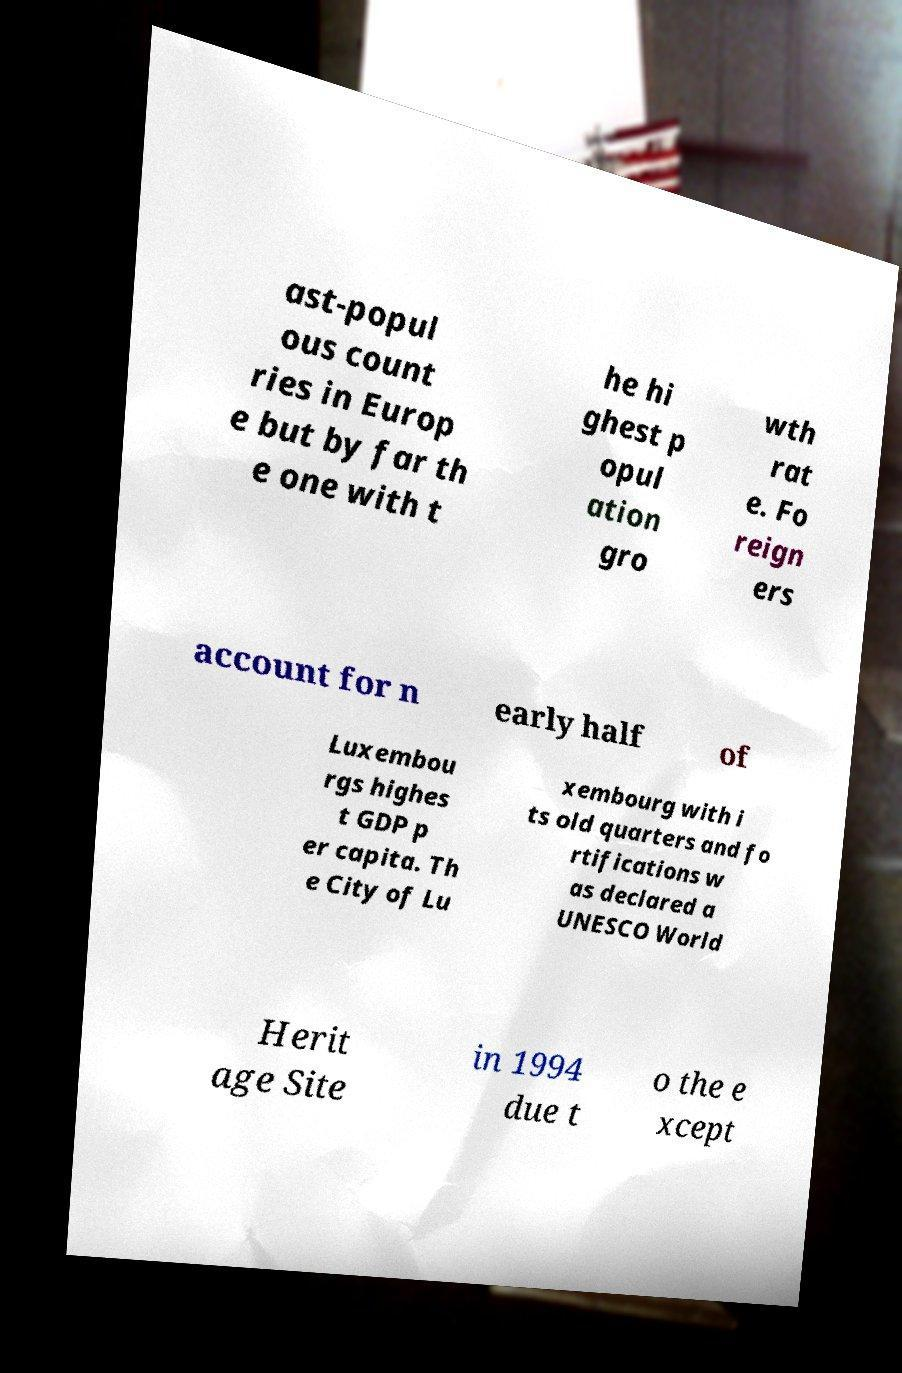Please identify and transcribe the text found in this image. ast-popul ous count ries in Europ e but by far th e one with t he hi ghest p opul ation gro wth rat e. Fo reign ers account for n early half of Luxembou rgs highes t GDP p er capita. Th e City of Lu xembourg with i ts old quarters and fo rtifications w as declared a UNESCO World Herit age Site in 1994 due t o the e xcept 